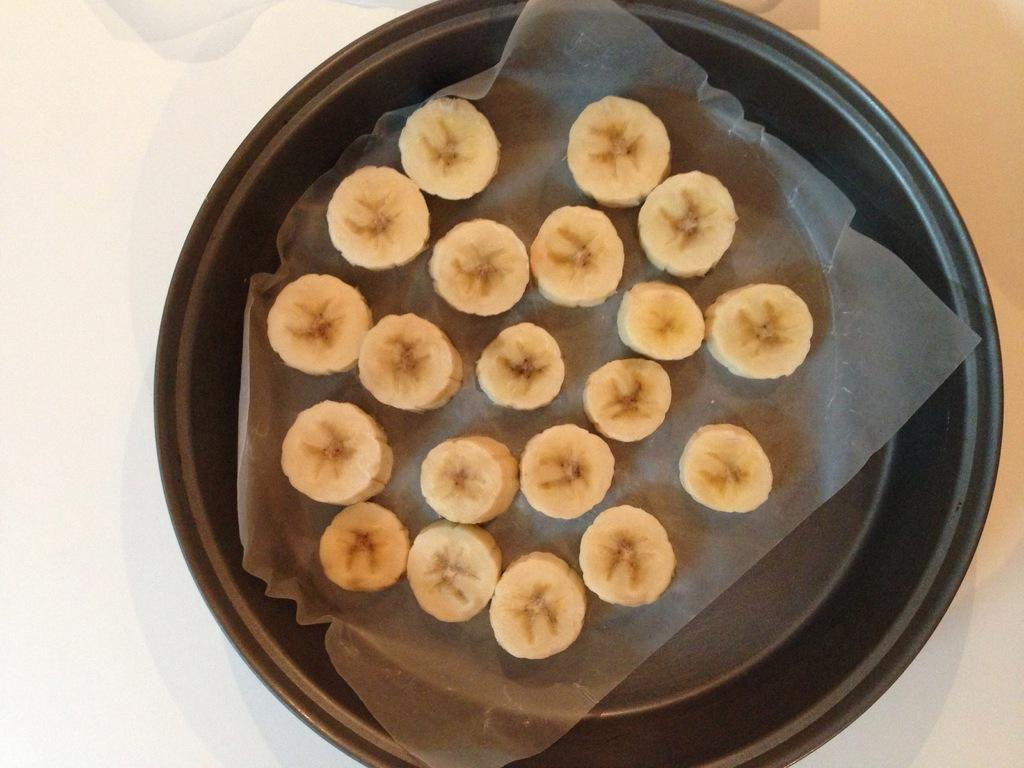What object is present on the plate in the image? There is a cover with a food item on the plate. What colors can be seen on the left and right sides of the image? There is a white color on the left side of the image and a yellow color on the right side of the image. What type of base is supporting the plate in the image? There is no base visible in the image; the plate appears to be resting on a flat surface. What subject is the son studying at school in the image? There is no son or school present in the image. 